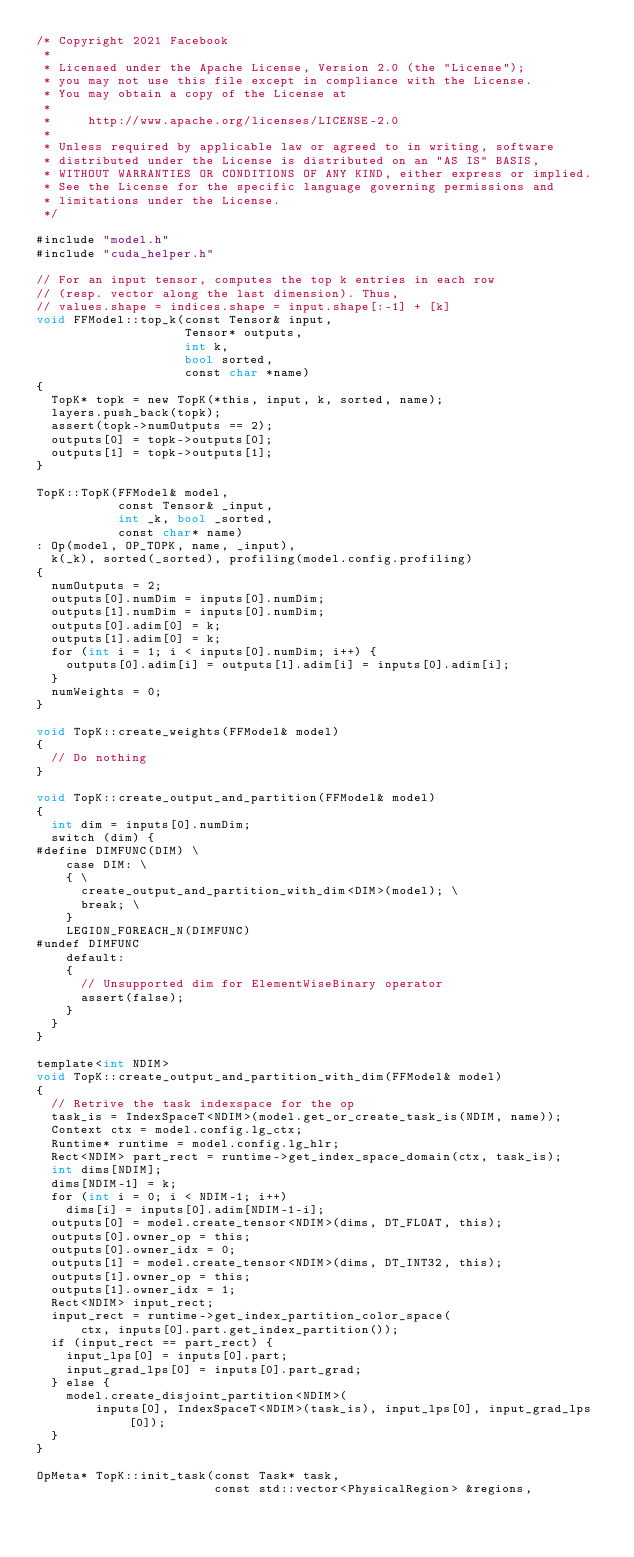Convert code to text. <code><loc_0><loc_0><loc_500><loc_500><_Cuda_>/* Copyright 2021 Facebook
 *
 * Licensed under the Apache License, Version 2.0 (the "License");
 * you may not use this file except in compliance with the License.
 * You may obtain a copy of the License at
 *
 *     http://www.apache.org/licenses/LICENSE-2.0
 *
 * Unless required by applicable law or agreed to in writing, software
 * distributed under the License is distributed on an "AS IS" BASIS,
 * WITHOUT WARRANTIES OR CONDITIONS OF ANY KIND, either express or implied.
 * See the License for the specific language governing permissions and
 * limitations under the License.
 */

#include "model.h"
#include "cuda_helper.h"

// For an input tensor, computes the top k entries in each row
// (resp. vector along the last dimension). Thus,
// values.shape = indices.shape = input.shape[:-1] + [k]
void FFModel::top_k(const Tensor& input,
                    Tensor* outputs,
                    int k,
                    bool sorted,
                    const char *name)
{
  TopK* topk = new TopK(*this, input, k, sorted, name);
  layers.push_back(topk);
  assert(topk->numOutputs == 2);
  outputs[0] = topk->outputs[0];
  outputs[1] = topk->outputs[1];
}

TopK::TopK(FFModel& model,
           const Tensor& _input,
           int _k, bool _sorted,
           const char* name)
: Op(model, OP_TOPK, name, _input),
  k(_k), sorted(_sorted), profiling(model.config.profiling)
{
  numOutputs = 2;
  outputs[0].numDim = inputs[0].numDim;
  outputs[1].numDim = inputs[0].numDim;
  outputs[0].adim[0] = k;
  outputs[1].adim[0] = k;
  for (int i = 1; i < inputs[0].numDim; i++) {
    outputs[0].adim[i] = outputs[1].adim[i] = inputs[0].adim[i];
  }
  numWeights = 0;
}

void TopK::create_weights(FFModel& model)
{
  // Do nothing
}

void TopK::create_output_and_partition(FFModel& model)
{
  int dim = inputs[0].numDim;
  switch (dim) {
#define DIMFUNC(DIM) \
    case DIM: \
    { \
      create_output_and_partition_with_dim<DIM>(model); \
      break; \
    }
    LEGION_FOREACH_N(DIMFUNC)
#undef DIMFUNC
    default:
    {
      // Unsupported dim for ElementWiseBinary operator
      assert(false);
    }
  }
}

template<int NDIM>
void TopK::create_output_and_partition_with_dim(FFModel& model)
{
  // Retrive the task indexspace for the op
  task_is = IndexSpaceT<NDIM>(model.get_or_create_task_is(NDIM, name));
  Context ctx = model.config.lg_ctx;
  Runtime* runtime = model.config.lg_hlr;
  Rect<NDIM> part_rect = runtime->get_index_space_domain(ctx, task_is);
  int dims[NDIM];
  dims[NDIM-1] = k;
  for (int i = 0; i < NDIM-1; i++)
    dims[i] = inputs[0].adim[NDIM-1-i];
  outputs[0] = model.create_tensor<NDIM>(dims, DT_FLOAT, this);
  outputs[0].owner_op = this;
  outputs[0].owner_idx = 0;
  outputs[1] = model.create_tensor<NDIM>(dims, DT_INT32, this);
  outputs[1].owner_op = this;
  outputs[1].owner_idx = 1;
  Rect<NDIM> input_rect;
  input_rect = runtime->get_index_partition_color_space(
      ctx, inputs[0].part.get_index_partition());
  if (input_rect == part_rect) {
    input_lps[0] = inputs[0].part;
    input_grad_lps[0] = inputs[0].part_grad;
  } else {
    model.create_disjoint_partition<NDIM>(
        inputs[0], IndexSpaceT<NDIM>(task_is), input_lps[0], input_grad_lps[0]);
  }
}

OpMeta* TopK::init_task(const Task* task,
                        const std::vector<PhysicalRegion> &regions,</code> 